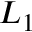Convert formula to latex. <formula><loc_0><loc_0><loc_500><loc_500>L _ { 1 }</formula> 